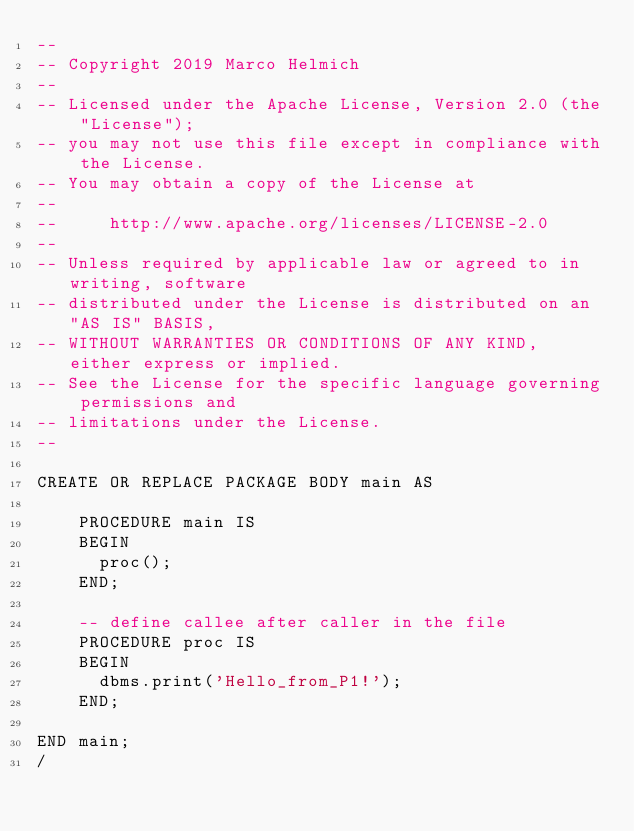Convert code to text. <code><loc_0><loc_0><loc_500><loc_500><_SQL_>--
-- Copyright 2019 Marco Helmich
--
-- Licensed under the Apache License, Version 2.0 (the "License");
-- you may not use this file except in compliance with the License.
-- You may obtain a copy of the License at
--
--     http://www.apache.org/licenses/LICENSE-2.0
--
-- Unless required by applicable law or agreed to in writing, software
-- distributed under the License is distributed on an "AS IS" BASIS,
-- WITHOUT WARRANTIES OR CONDITIONS OF ANY KIND, either express or implied.
-- See the License for the specific language governing permissions and
-- limitations under the License.
--

CREATE OR REPLACE PACKAGE BODY main AS

    PROCEDURE main IS
    BEGIN
      proc();
    END;

    -- define callee after caller in the file
    PROCEDURE proc IS
    BEGIN
      dbms.print('Hello_from_P1!');
    END;

END main;
/
</code> 